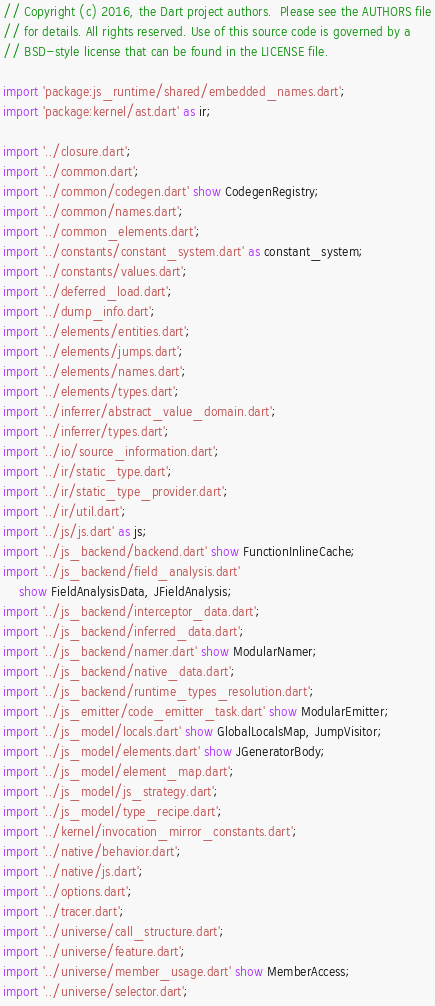<code> <loc_0><loc_0><loc_500><loc_500><_Dart_>// Copyright (c) 2016, the Dart project authors.  Please see the AUTHORS file
// for details. All rights reserved. Use of this source code is governed by a
// BSD-style license that can be found in the LICENSE file.

import 'package:js_runtime/shared/embedded_names.dart';
import 'package:kernel/ast.dart' as ir;

import '../closure.dart';
import '../common.dart';
import '../common/codegen.dart' show CodegenRegistry;
import '../common/names.dart';
import '../common_elements.dart';
import '../constants/constant_system.dart' as constant_system;
import '../constants/values.dart';
import '../deferred_load.dart';
import '../dump_info.dart';
import '../elements/entities.dart';
import '../elements/jumps.dart';
import '../elements/names.dart';
import '../elements/types.dart';
import '../inferrer/abstract_value_domain.dart';
import '../inferrer/types.dart';
import '../io/source_information.dart';
import '../ir/static_type.dart';
import '../ir/static_type_provider.dart';
import '../ir/util.dart';
import '../js/js.dart' as js;
import '../js_backend/backend.dart' show FunctionInlineCache;
import '../js_backend/field_analysis.dart'
    show FieldAnalysisData, JFieldAnalysis;
import '../js_backend/interceptor_data.dart';
import '../js_backend/inferred_data.dart';
import '../js_backend/namer.dart' show ModularNamer;
import '../js_backend/native_data.dart';
import '../js_backend/runtime_types_resolution.dart';
import '../js_emitter/code_emitter_task.dart' show ModularEmitter;
import '../js_model/locals.dart' show GlobalLocalsMap, JumpVisitor;
import '../js_model/elements.dart' show JGeneratorBody;
import '../js_model/element_map.dart';
import '../js_model/js_strategy.dart';
import '../js_model/type_recipe.dart';
import '../kernel/invocation_mirror_constants.dart';
import '../native/behavior.dart';
import '../native/js.dart';
import '../options.dart';
import '../tracer.dart';
import '../universe/call_structure.dart';
import '../universe/feature.dart';
import '../universe/member_usage.dart' show MemberAccess;
import '../universe/selector.dart';</code> 